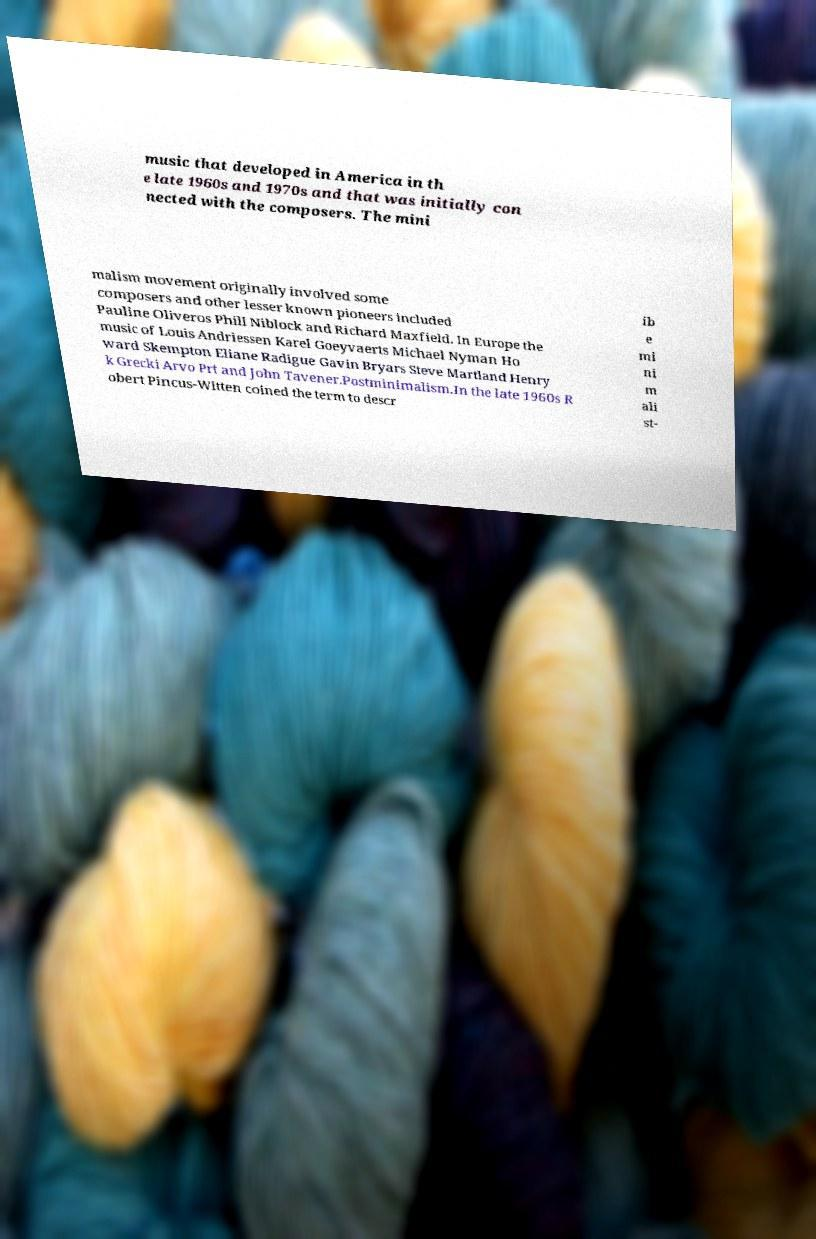Can you read and provide the text displayed in the image?This photo seems to have some interesting text. Can you extract and type it out for me? music that developed in America in th e late 1960s and 1970s and that was initially con nected with the composers. The mini malism movement originally involved some composers and other lesser known pioneers included Pauline Oliveros Phill Niblock and Richard Maxfield. In Europe the music of Louis Andriessen Karel Goeyvaerts Michael Nyman Ho ward Skempton Eliane Radigue Gavin Bryars Steve Martland Henry k Grecki Arvo Prt and John Tavener.Postminimalism.In the late 1960s R obert Pincus-Witten coined the term to descr ib e mi ni m ali st- 